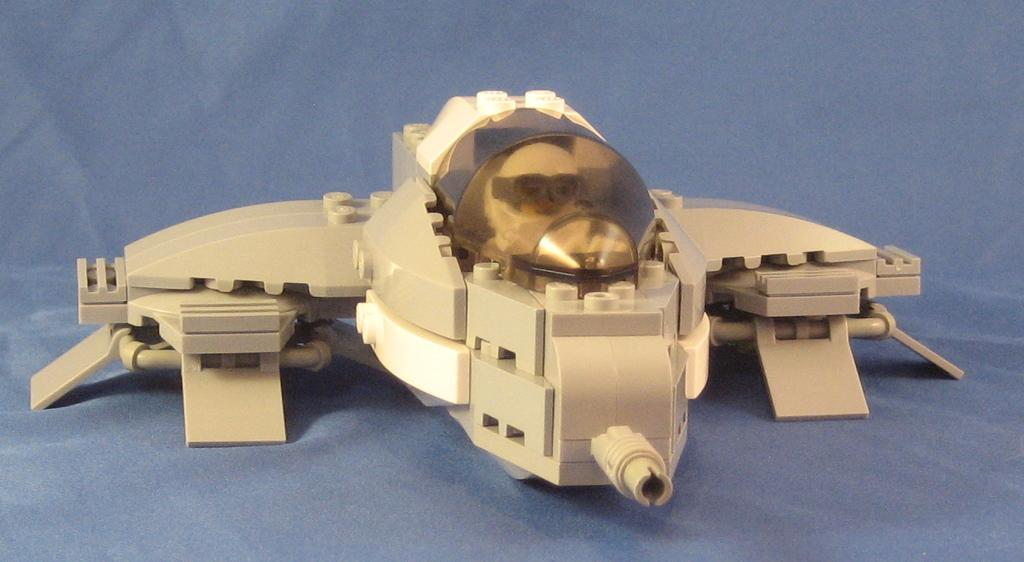What is the main subject of the image? There is a depiction of an aeroplane in the image. What color is the surface behind the aeroplane? The surface behind the aeroplane is blue. Is the aeroplane stuck in quicksand in the image? No, there is no quicksand present in the image, and the aeroplane is not depicted as being stuck. What type of guitar can be seen in the image? There is no guitar present in the image; it features a depiction of an aeroplane and a blue surface. 